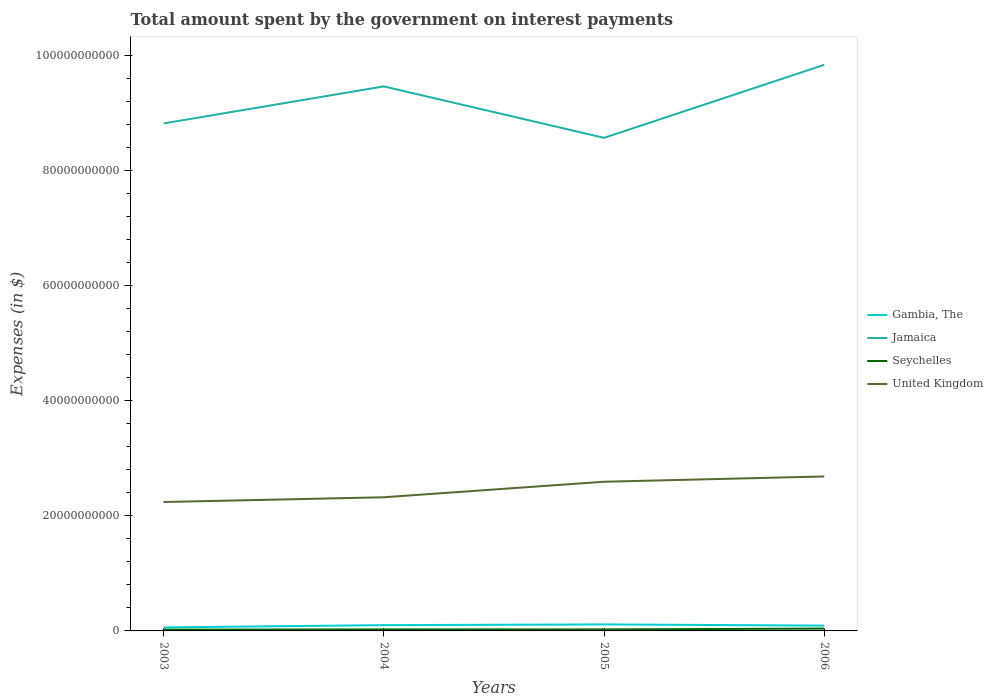Does the line corresponding to United Kingdom intersect with the line corresponding to Seychelles?
Give a very brief answer. No. Is the number of lines equal to the number of legend labels?
Your response must be concise. Yes. Across all years, what is the maximum amount spent on interest payments by the government in Gambia, The?
Your answer should be very brief. 6.07e+08. What is the total amount spent on interest payments by the government in Gambia, The in the graph?
Your answer should be very brief. -5.24e+08. What is the difference between the highest and the second highest amount spent on interest payments by the government in Seychelles?
Make the answer very short. 1.88e+08. How many lines are there?
Keep it short and to the point. 4. How many years are there in the graph?
Provide a succinct answer. 4. What is the difference between two consecutive major ticks on the Y-axis?
Your answer should be very brief. 2.00e+1. Are the values on the major ticks of Y-axis written in scientific E-notation?
Offer a terse response. No. Where does the legend appear in the graph?
Your answer should be very brief. Center right. How many legend labels are there?
Make the answer very short. 4. How are the legend labels stacked?
Provide a succinct answer. Vertical. What is the title of the graph?
Make the answer very short. Total amount spent by the government on interest payments. Does "Spain" appear as one of the legend labels in the graph?
Keep it short and to the point. No. What is the label or title of the X-axis?
Make the answer very short. Years. What is the label or title of the Y-axis?
Give a very brief answer. Expenses (in $). What is the Expenses (in $) in Gambia, The in 2003?
Make the answer very short. 6.07e+08. What is the Expenses (in $) in Jamaica in 2003?
Give a very brief answer. 8.82e+1. What is the Expenses (in $) of Seychelles in 2003?
Your answer should be very brief. 2.18e+08. What is the Expenses (in $) in United Kingdom in 2003?
Your answer should be compact. 2.24e+1. What is the Expenses (in $) in Gambia, The in 2004?
Ensure brevity in your answer.  1.00e+09. What is the Expenses (in $) in Jamaica in 2004?
Offer a terse response. 9.46e+1. What is the Expenses (in $) of Seychelles in 2004?
Your response must be concise. 2.64e+08. What is the Expenses (in $) of United Kingdom in 2004?
Offer a very short reply. 2.32e+1. What is the Expenses (in $) in Gambia, The in 2005?
Keep it short and to the point. 1.13e+09. What is the Expenses (in $) in Jamaica in 2005?
Your answer should be very brief. 8.57e+1. What is the Expenses (in $) in Seychelles in 2005?
Provide a short and direct response. 2.60e+08. What is the Expenses (in $) of United Kingdom in 2005?
Give a very brief answer. 2.59e+1. What is the Expenses (in $) of Gambia, The in 2006?
Your answer should be compact. 9.21e+08. What is the Expenses (in $) in Jamaica in 2006?
Your answer should be compact. 9.84e+1. What is the Expenses (in $) of Seychelles in 2006?
Make the answer very short. 4.06e+08. What is the Expenses (in $) in United Kingdom in 2006?
Your answer should be very brief. 2.68e+1. Across all years, what is the maximum Expenses (in $) of Gambia, The?
Your answer should be compact. 1.13e+09. Across all years, what is the maximum Expenses (in $) in Jamaica?
Keep it short and to the point. 9.84e+1. Across all years, what is the maximum Expenses (in $) in Seychelles?
Your response must be concise. 4.06e+08. Across all years, what is the maximum Expenses (in $) of United Kingdom?
Your response must be concise. 2.68e+1. Across all years, what is the minimum Expenses (in $) in Gambia, The?
Offer a terse response. 6.07e+08. Across all years, what is the minimum Expenses (in $) of Jamaica?
Offer a very short reply. 8.57e+1. Across all years, what is the minimum Expenses (in $) in Seychelles?
Offer a terse response. 2.18e+08. Across all years, what is the minimum Expenses (in $) in United Kingdom?
Keep it short and to the point. 2.24e+1. What is the total Expenses (in $) of Gambia, The in the graph?
Offer a very short reply. 3.66e+09. What is the total Expenses (in $) of Jamaica in the graph?
Your answer should be very brief. 3.67e+11. What is the total Expenses (in $) of Seychelles in the graph?
Ensure brevity in your answer.  1.15e+09. What is the total Expenses (in $) of United Kingdom in the graph?
Your response must be concise. 9.84e+1. What is the difference between the Expenses (in $) of Gambia, The in 2003 and that in 2004?
Your answer should be compact. -3.96e+08. What is the difference between the Expenses (in $) of Jamaica in 2003 and that in 2004?
Your answer should be very brief. -6.43e+09. What is the difference between the Expenses (in $) of Seychelles in 2003 and that in 2004?
Give a very brief answer. -4.60e+07. What is the difference between the Expenses (in $) in United Kingdom in 2003 and that in 2004?
Keep it short and to the point. -8.25e+08. What is the difference between the Expenses (in $) in Gambia, The in 2003 and that in 2005?
Offer a very short reply. -5.24e+08. What is the difference between the Expenses (in $) in Jamaica in 2003 and that in 2005?
Your response must be concise. 2.50e+09. What is the difference between the Expenses (in $) of Seychelles in 2003 and that in 2005?
Provide a succinct answer. -4.27e+07. What is the difference between the Expenses (in $) of United Kingdom in 2003 and that in 2005?
Make the answer very short. -3.52e+09. What is the difference between the Expenses (in $) of Gambia, The in 2003 and that in 2006?
Make the answer very short. -3.14e+08. What is the difference between the Expenses (in $) of Jamaica in 2003 and that in 2006?
Provide a succinct answer. -1.02e+1. What is the difference between the Expenses (in $) in Seychelles in 2003 and that in 2006?
Ensure brevity in your answer.  -1.88e+08. What is the difference between the Expenses (in $) of United Kingdom in 2003 and that in 2006?
Make the answer very short. -4.44e+09. What is the difference between the Expenses (in $) in Gambia, The in 2004 and that in 2005?
Make the answer very short. -1.28e+08. What is the difference between the Expenses (in $) of Jamaica in 2004 and that in 2005?
Your response must be concise. 8.94e+09. What is the difference between the Expenses (in $) in Seychelles in 2004 and that in 2005?
Provide a succinct answer. 3.27e+06. What is the difference between the Expenses (in $) of United Kingdom in 2004 and that in 2005?
Keep it short and to the point. -2.69e+09. What is the difference between the Expenses (in $) in Gambia, The in 2004 and that in 2006?
Provide a short and direct response. 8.17e+07. What is the difference between the Expenses (in $) in Jamaica in 2004 and that in 2006?
Ensure brevity in your answer.  -3.75e+09. What is the difference between the Expenses (in $) in Seychelles in 2004 and that in 2006?
Your answer should be compact. -1.42e+08. What is the difference between the Expenses (in $) of United Kingdom in 2004 and that in 2006?
Give a very brief answer. -3.61e+09. What is the difference between the Expenses (in $) of Gambia, The in 2005 and that in 2006?
Ensure brevity in your answer.  2.10e+08. What is the difference between the Expenses (in $) of Jamaica in 2005 and that in 2006?
Your response must be concise. -1.27e+1. What is the difference between the Expenses (in $) in Seychelles in 2005 and that in 2006?
Give a very brief answer. -1.46e+08. What is the difference between the Expenses (in $) of United Kingdom in 2005 and that in 2006?
Give a very brief answer. -9.20e+08. What is the difference between the Expenses (in $) in Gambia, The in 2003 and the Expenses (in $) in Jamaica in 2004?
Make the answer very short. -9.40e+1. What is the difference between the Expenses (in $) in Gambia, The in 2003 and the Expenses (in $) in Seychelles in 2004?
Offer a terse response. 3.44e+08. What is the difference between the Expenses (in $) of Gambia, The in 2003 and the Expenses (in $) of United Kingdom in 2004?
Make the answer very short. -2.26e+1. What is the difference between the Expenses (in $) of Jamaica in 2003 and the Expenses (in $) of Seychelles in 2004?
Your response must be concise. 8.79e+1. What is the difference between the Expenses (in $) in Jamaica in 2003 and the Expenses (in $) in United Kingdom in 2004?
Keep it short and to the point. 6.49e+1. What is the difference between the Expenses (in $) in Seychelles in 2003 and the Expenses (in $) in United Kingdom in 2004?
Your response must be concise. -2.30e+1. What is the difference between the Expenses (in $) of Gambia, The in 2003 and the Expenses (in $) of Jamaica in 2005?
Your response must be concise. -8.51e+1. What is the difference between the Expenses (in $) in Gambia, The in 2003 and the Expenses (in $) in Seychelles in 2005?
Make the answer very short. 3.47e+08. What is the difference between the Expenses (in $) of Gambia, The in 2003 and the Expenses (in $) of United Kingdom in 2005?
Give a very brief answer. -2.53e+1. What is the difference between the Expenses (in $) in Jamaica in 2003 and the Expenses (in $) in Seychelles in 2005?
Your response must be concise. 8.79e+1. What is the difference between the Expenses (in $) in Jamaica in 2003 and the Expenses (in $) in United Kingdom in 2005?
Your answer should be very brief. 6.23e+1. What is the difference between the Expenses (in $) of Seychelles in 2003 and the Expenses (in $) of United Kingdom in 2005?
Your response must be concise. -2.57e+1. What is the difference between the Expenses (in $) of Gambia, The in 2003 and the Expenses (in $) of Jamaica in 2006?
Provide a short and direct response. -9.77e+1. What is the difference between the Expenses (in $) in Gambia, The in 2003 and the Expenses (in $) in Seychelles in 2006?
Keep it short and to the point. 2.02e+08. What is the difference between the Expenses (in $) of Gambia, The in 2003 and the Expenses (in $) of United Kingdom in 2006?
Ensure brevity in your answer.  -2.62e+1. What is the difference between the Expenses (in $) of Jamaica in 2003 and the Expenses (in $) of Seychelles in 2006?
Provide a short and direct response. 8.78e+1. What is the difference between the Expenses (in $) of Jamaica in 2003 and the Expenses (in $) of United Kingdom in 2006?
Ensure brevity in your answer.  6.13e+1. What is the difference between the Expenses (in $) of Seychelles in 2003 and the Expenses (in $) of United Kingdom in 2006?
Your response must be concise. -2.66e+1. What is the difference between the Expenses (in $) of Gambia, The in 2004 and the Expenses (in $) of Jamaica in 2005?
Ensure brevity in your answer.  -8.47e+1. What is the difference between the Expenses (in $) in Gambia, The in 2004 and the Expenses (in $) in Seychelles in 2005?
Offer a terse response. 7.43e+08. What is the difference between the Expenses (in $) of Gambia, The in 2004 and the Expenses (in $) of United Kingdom in 2005?
Your answer should be compact. -2.49e+1. What is the difference between the Expenses (in $) in Jamaica in 2004 and the Expenses (in $) in Seychelles in 2005?
Ensure brevity in your answer.  9.43e+1. What is the difference between the Expenses (in $) of Jamaica in 2004 and the Expenses (in $) of United Kingdom in 2005?
Your response must be concise. 6.87e+1. What is the difference between the Expenses (in $) of Seychelles in 2004 and the Expenses (in $) of United Kingdom in 2005?
Keep it short and to the point. -2.57e+1. What is the difference between the Expenses (in $) of Gambia, The in 2004 and the Expenses (in $) of Jamaica in 2006?
Keep it short and to the point. -9.74e+1. What is the difference between the Expenses (in $) of Gambia, The in 2004 and the Expenses (in $) of Seychelles in 2006?
Give a very brief answer. 5.97e+08. What is the difference between the Expenses (in $) in Gambia, The in 2004 and the Expenses (in $) in United Kingdom in 2006?
Provide a succinct answer. -2.58e+1. What is the difference between the Expenses (in $) in Jamaica in 2004 and the Expenses (in $) in Seychelles in 2006?
Ensure brevity in your answer.  9.42e+1. What is the difference between the Expenses (in $) in Jamaica in 2004 and the Expenses (in $) in United Kingdom in 2006?
Your answer should be compact. 6.78e+1. What is the difference between the Expenses (in $) in Seychelles in 2004 and the Expenses (in $) in United Kingdom in 2006?
Provide a short and direct response. -2.66e+1. What is the difference between the Expenses (in $) in Gambia, The in 2005 and the Expenses (in $) in Jamaica in 2006?
Your answer should be compact. -9.72e+1. What is the difference between the Expenses (in $) in Gambia, The in 2005 and the Expenses (in $) in Seychelles in 2006?
Provide a short and direct response. 7.25e+08. What is the difference between the Expenses (in $) in Gambia, The in 2005 and the Expenses (in $) in United Kingdom in 2006?
Your answer should be very brief. -2.57e+1. What is the difference between the Expenses (in $) of Jamaica in 2005 and the Expenses (in $) of Seychelles in 2006?
Offer a very short reply. 8.53e+1. What is the difference between the Expenses (in $) of Jamaica in 2005 and the Expenses (in $) of United Kingdom in 2006?
Give a very brief answer. 5.88e+1. What is the difference between the Expenses (in $) in Seychelles in 2005 and the Expenses (in $) in United Kingdom in 2006?
Your answer should be compact. -2.66e+1. What is the average Expenses (in $) in Gambia, The per year?
Your answer should be compact. 9.16e+08. What is the average Expenses (in $) of Jamaica per year?
Provide a succinct answer. 9.17e+1. What is the average Expenses (in $) of Seychelles per year?
Ensure brevity in your answer.  2.87e+08. What is the average Expenses (in $) of United Kingdom per year?
Offer a terse response. 2.46e+1. In the year 2003, what is the difference between the Expenses (in $) in Gambia, The and Expenses (in $) in Jamaica?
Provide a short and direct response. -8.76e+1. In the year 2003, what is the difference between the Expenses (in $) of Gambia, The and Expenses (in $) of Seychelles?
Your answer should be very brief. 3.90e+08. In the year 2003, what is the difference between the Expenses (in $) of Gambia, The and Expenses (in $) of United Kingdom?
Provide a short and direct response. -2.18e+1. In the year 2003, what is the difference between the Expenses (in $) in Jamaica and Expenses (in $) in Seychelles?
Keep it short and to the point. 8.80e+1. In the year 2003, what is the difference between the Expenses (in $) in Jamaica and Expenses (in $) in United Kingdom?
Offer a very short reply. 6.58e+1. In the year 2003, what is the difference between the Expenses (in $) in Seychelles and Expenses (in $) in United Kingdom?
Make the answer very short. -2.22e+1. In the year 2004, what is the difference between the Expenses (in $) of Gambia, The and Expenses (in $) of Jamaica?
Offer a terse response. -9.36e+1. In the year 2004, what is the difference between the Expenses (in $) of Gambia, The and Expenses (in $) of Seychelles?
Offer a terse response. 7.40e+08. In the year 2004, what is the difference between the Expenses (in $) of Gambia, The and Expenses (in $) of United Kingdom?
Give a very brief answer. -2.22e+1. In the year 2004, what is the difference between the Expenses (in $) of Jamaica and Expenses (in $) of Seychelles?
Offer a very short reply. 9.43e+1. In the year 2004, what is the difference between the Expenses (in $) of Jamaica and Expenses (in $) of United Kingdom?
Offer a very short reply. 7.14e+1. In the year 2004, what is the difference between the Expenses (in $) in Seychelles and Expenses (in $) in United Kingdom?
Your response must be concise. -2.30e+1. In the year 2005, what is the difference between the Expenses (in $) in Gambia, The and Expenses (in $) in Jamaica?
Give a very brief answer. -8.45e+1. In the year 2005, what is the difference between the Expenses (in $) in Gambia, The and Expenses (in $) in Seychelles?
Keep it short and to the point. 8.71e+08. In the year 2005, what is the difference between the Expenses (in $) of Gambia, The and Expenses (in $) of United Kingdom?
Your response must be concise. -2.48e+1. In the year 2005, what is the difference between the Expenses (in $) in Jamaica and Expenses (in $) in Seychelles?
Make the answer very short. 8.54e+1. In the year 2005, what is the difference between the Expenses (in $) of Jamaica and Expenses (in $) of United Kingdom?
Offer a terse response. 5.98e+1. In the year 2005, what is the difference between the Expenses (in $) of Seychelles and Expenses (in $) of United Kingdom?
Your answer should be very brief. -2.57e+1. In the year 2006, what is the difference between the Expenses (in $) in Gambia, The and Expenses (in $) in Jamaica?
Your answer should be very brief. -9.74e+1. In the year 2006, what is the difference between the Expenses (in $) in Gambia, The and Expenses (in $) in Seychelles?
Offer a very short reply. 5.16e+08. In the year 2006, what is the difference between the Expenses (in $) of Gambia, The and Expenses (in $) of United Kingdom?
Provide a short and direct response. -2.59e+1. In the year 2006, what is the difference between the Expenses (in $) in Jamaica and Expenses (in $) in Seychelles?
Offer a terse response. 9.79e+1. In the year 2006, what is the difference between the Expenses (in $) of Jamaica and Expenses (in $) of United Kingdom?
Make the answer very short. 7.15e+1. In the year 2006, what is the difference between the Expenses (in $) in Seychelles and Expenses (in $) in United Kingdom?
Offer a terse response. -2.64e+1. What is the ratio of the Expenses (in $) in Gambia, The in 2003 to that in 2004?
Your answer should be very brief. 0.61. What is the ratio of the Expenses (in $) of Jamaica in 2003 to that in 2004?
Your answer should be compact. 0.93. What is the ratio of the Expenses (in $) in Seychelles in 2003 to that in 2004?
Your response must be concise. 0.83. What is the ratio of the Expenses (in $) of United Kingdom in 2003 to that in 2004?
Provide a succinct answer. 0.96. What is the ratio of the Expenses (in $) in Gambia, The in 2003 to that in 2005?
Provide a short and direct response. 0.54. What is the ratio of the Expenses (in $) of Jamaica in 2003 to that in 2005?
Your answer should be very brief. 1.03. What is the ratio of the Expenses (in $) of Seychelles in 2003 to that in 2005?
Your answer should be very brief. 0.84. What is the ratio of the Expenses (in $) in United Kingdom in 2003 to that in 2005?
Make the answer very short. 0.86. What is the ratio of the Expenses (in $) in Gambia, The in 2003 to that in 2006?
Keep it short and to the point. 0.66. What is the ratio of the Expenses (in $) of Jamaica in 2003 to that in 2006?
Offer a very short reply. 0.9. What is the ratio of the Expenses (in $) in Seychelles in 2003 to that in 2006?
Give a very brief answer. 0.54. What is the ratio of the Expenses (in $) of United Kingdom in 2003 to that in 2006?
Provide a succinct answer. 0.83. What is the ratio of the Expenses (in $) in Gambia, The in 2004 to that in 2005?
Provide a short and direct response. 0.89. What is the ratio of the Expenses (in $) of Jamaica in 2004 to that in 2005?
Make the answer very short. 1.1. What is the ratio of the Expenses (in $) in Seychelles in 2004 to that in 2005?
Offer a terse response. 1.01. What is the ratio of the Expenses (in $) in United Kingdom in 2004 to that in 2005?
Keep it short and to the point. 0.9. What is the ratio of the Expenses (in $) of Gambia, The in 2004 to that in 2006?
Give a very brief answer. 1.09. What is the ratio of the Expenses (in $) in Jamaica in 2004 to that in 2006?
Provide a short and direct response. 0.96. What is the ratio of the Expenses (in $) of Seychelles in 2004 to that in 2006?
Your answer should be compact. 0.65. What is the ratio of the Expenses (in $) of United Kingdom in 2004 to that in 2006?
Give a very brief answer. 0.87. What is the ratio of the Expenses (in $) in Gambia, The in 2005 to that in 2006?
Offer a terse response. 1.23. What is the ratio of the Expenses (in $) in Jamaica in 2005 to that in 2006?
Keep it short and to the point. 0.87. What is the ratio of the Expenses (in $) of Seychelles in 2005 to that in 2006?
Give a very brief answer. 0.64. What is the ratio of the Expenses (in $) of United Kingdom in 2005 to that in 2006?
Your answer should be compact. 0.97. What is the difference between the highest and the second highest Expenses (in $) in Gambia, The?
Your response must be concise. 1.28e+08. What is the difference between the highest and the second highest Expenses (in $) in Jamaica?
Your answer should be very brief. 3.75e+09. What is the difference between the highest and the second highest Expenses (in $) in Seychelles?
Keep it short and to the point. 1.42e+08. What is the difference between the highest and the second highest Expenses (in $) of United Kingdom?
Provide a short and direct response. 9.20e+08. What is the difference between the highest and the lowest Expenses (in $) of Gambia, The?
Your response must be concise. 5.24e+08. What is the difference between the highest and the lowest Expenses (in $) of Jamaica?
Ensure brevity in your answer.  1.27e+1. What is the difference between the highest and the lowest Expenses (in $) in Seychelles?
Provide a short and direct response. 1.88e+08. What is the difference between the highest and the lowest Expenses (in $) in United Kingdom?
Ensure brevity in your answer.  4.44e+09. 